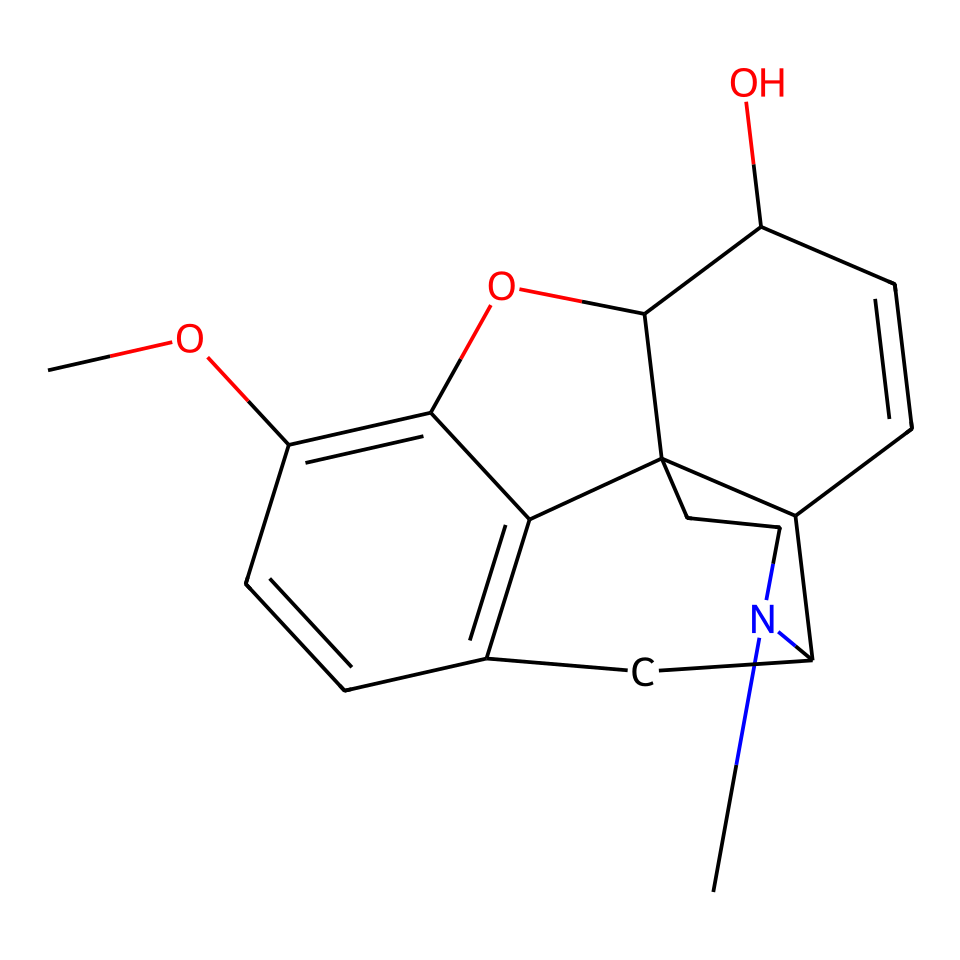What is the primary functional group present in codeine? The chemical structure of codeine contains a hydroxyl group (-OH) which is indicative of phenolic compounds. Additionally, the presence of a nitrogen atom points towards the amine functional group relevant to its classification as an alkaloid.
Answer: hydroxyl group How many carbon atoms are present in codeine? By analyzing the SMILES representation of codeine, we can count the number of 'C' in the structure. The structure contains 18 carbon atoms represented in various parts of the molecular framework.
Answer: 18 How many oxygen atoms are present in codeine? In the provided SMILES, there are two instances of the letter 'O', indicating the presence of two oxygen atoms in the chemical structure of codeine.
Answer: 2 Is codeine a basic or acidic compound? Codeine contains a nitrogen atom, which makes it basic in nature, characteristic of most alkaloids due to their structure and properties.
Answer: basic What is the molecular weight of codeine? To find the molecular weight, the atomic weights of each atom in the structure (C, H, N, O) are added based on the number of atoms present. By calculating, the approximate molecular weight of codeine is found to be around 299.36 g/mol.
Answer: 299.36 How does the nitrogen atom contribute to the structure of codeine? The nitrogen atom in codeine indicates that it contains an amine group, which can participate in hydrogen bonding and affects the solubility and interaction with biological systems, contributing to its effectiveness as an analgesic.
Answer: amine group What classification does codeine fall under based on its structure? The structure shows features typical of opiates, thus it classifies codeine as an opioid, a subclass of alkaloids used primarily for pain management.
Answer: opioid 